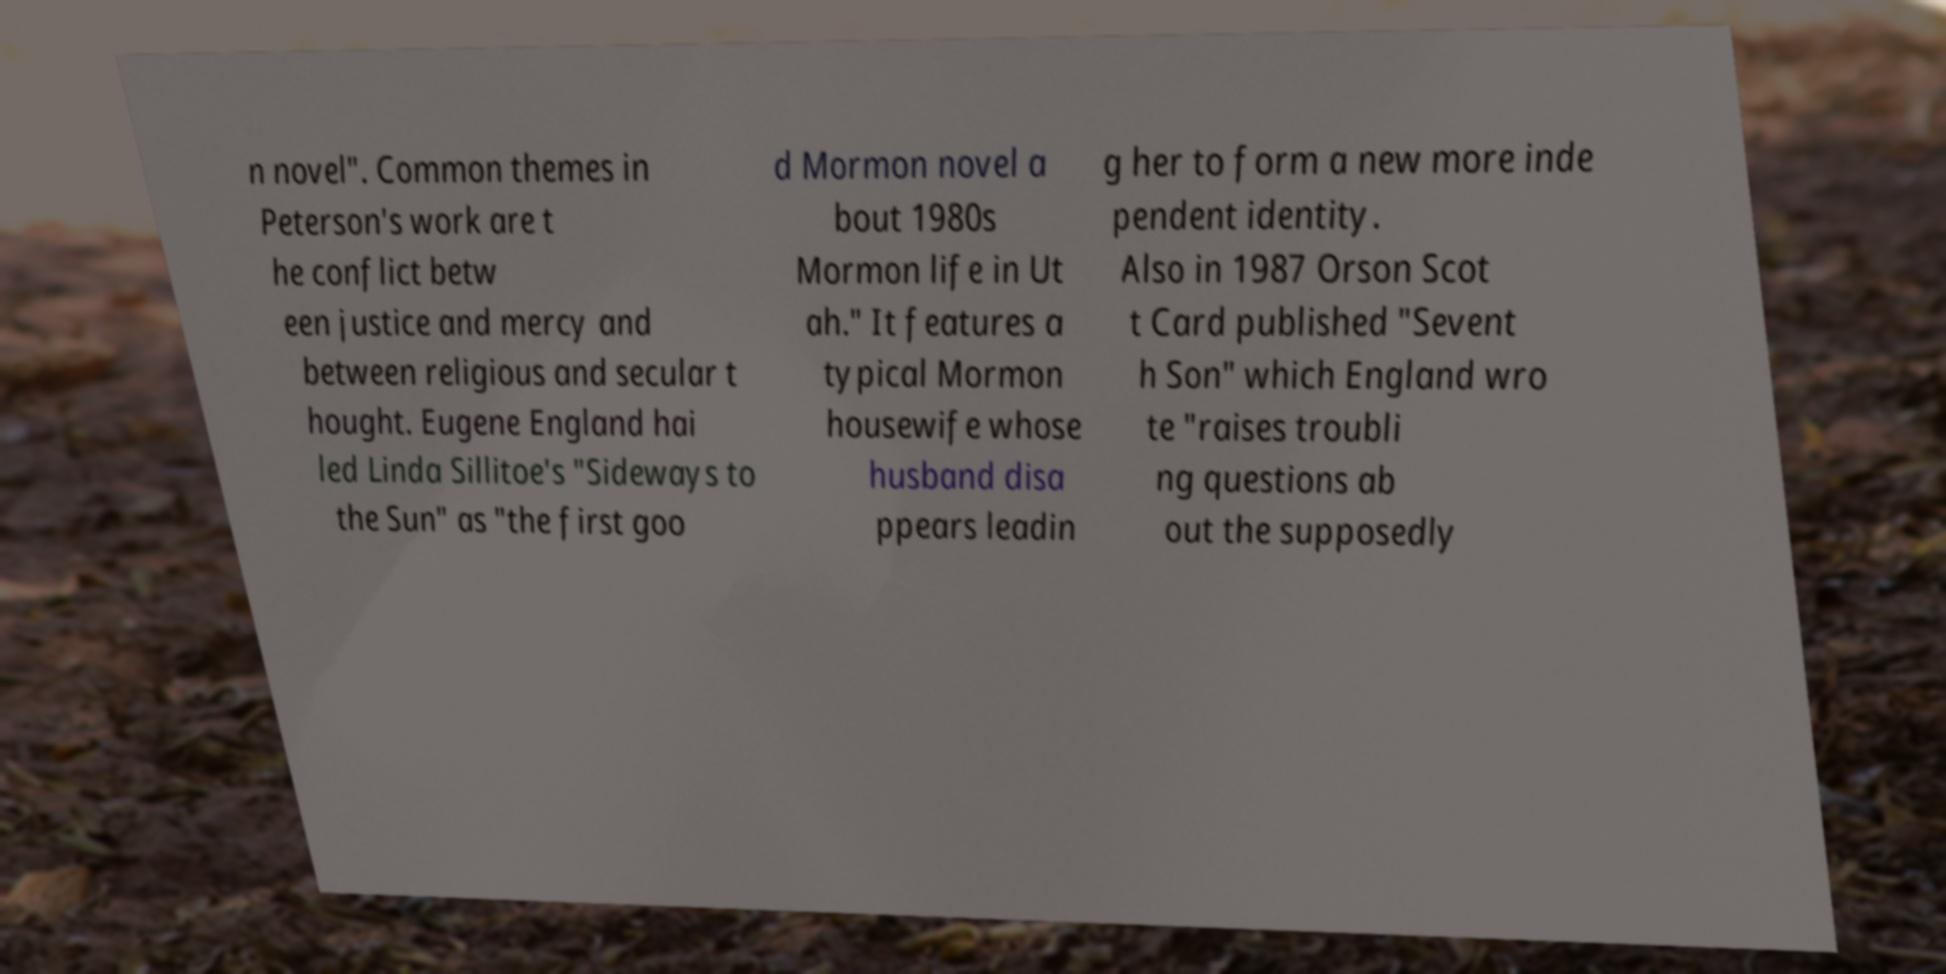Could you extract and type out the text from this image? n novel". Common themes in Peterson's work are t he conflict betw een justice and mercy and between religious and secular t hought. Eugene England hai led Linda Sillitoe's "Sideways to the Sun" as "the first goo d Mormon novel a bout 1980s Mormon life in Ut ah." It features a typical Mormon housewife whose husband disa ppears leadin g her to form a new more inde pendent identity. Also in 1987 Orson Scot t Card published "Sevent h Son" which England wro te "raises troubli ng questions ab out the supposedly 